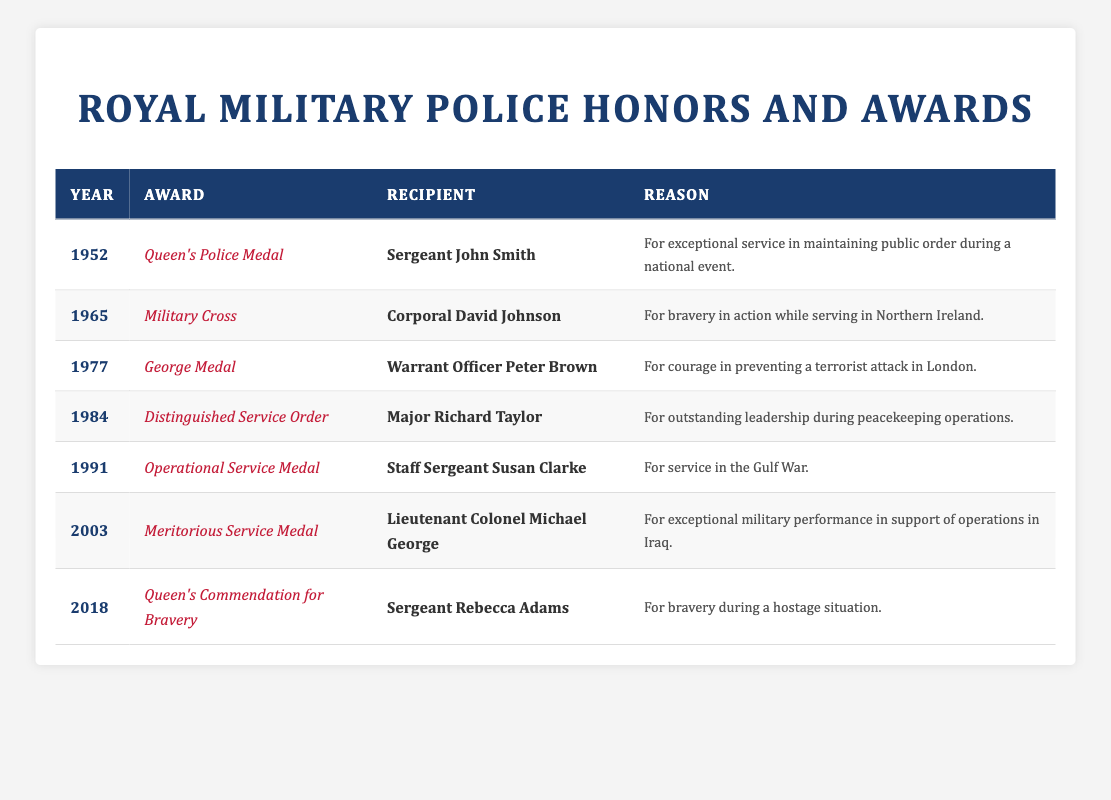What year did Sergeant John Smith receive the Queen's Police Medal? The table indicates that Sergeant John Smith received the Queen's Police Medal in the year 1952.
Answer: 1952 How many different awards are listed in the table? By counting all unique award names in the table, we see there are 7 awards: Queen's Police Medal, Military Cross, George Medal, Distinguished Service Order, Operational Service Medal, Meritorious Service Medal, and Queen's Commendation for Bravery.
Answer: 7 Who received the Meritorious Service Medal? The table shows that the Meritorious Service Medal was awarded to Lieutenant Colonel Michael George.
Answer: Lieutenant Colonel Michael George In which year did the Royal Military Police receive the Operational Service Medal? The table indicates that the Operational Service Medal was awarded in 1991.
Answer: 1991 Was there any award given for service in the Gulf War? Yes, according to the table, the Operational Service Medal was awarded for service in the Gulf War, specifically to Staff Sergeant Susan Clarke in 1991.
Answer: Yes What is the difference between the earliest and latest award years listed in the table? The earliest award year is 1952, and the latest is 2018. The difference can be calculated as 2018 - 1952 = 66 years.
Answer: 66 years Who has the longest span of service to receive their honors? The recipients from each award year show that Sergeant John Smith received his honor in 1952, and the most recent is Sergeant Rebecca Adams in 2018. No specific individual can be determined to have a longer span based solely on the awarded years.
Answer: Not applicable For how many awards was bravery the reason cited? Analyzing the table, bravery is specifically noted for the Military Cross awarded to Corporal David Johnson in 1965, the George Medal to Warrant Officer Peter Brown in 1977, and the Queen's Commendation for Bravery to Sergeant Rebecca Adams in 2018. This totals to 3 awards.
Answer: 3 awards What is the highest award listed in the table? The table includes various awards, but the Distinguished Service Order is often recognized as one of the highest forms of military honors, along with others such as the George Medal and Military Cross. However, in this context, the Distinguished Service Order is noted for outstanding leadership, indicating its high standing in military accolades.
Answer: Distinguished Service Order 